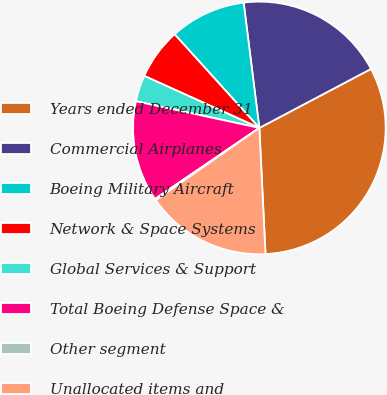Convert chart to OTSL. <chart><loc_0><loc_0><loc_500><loc_500><pie_chart><fcel>Years ended December 31<fcel>Commercial Airplanes<fcel>Boeing Military Aircraft<fcel>Network & Space Systems<fcel>Global Services & Support<fcel>Total Boeing Defense Space &<fcel>Other segment<fcel>Unallocated items and<nl><fcel>31.96%<fcel>19.25%<fcel>9.72%<fcel>6.54%<fcel>3.37%<fcel>12.9%<fcel>0.19%<fcel>16.07%<nl></chart> 